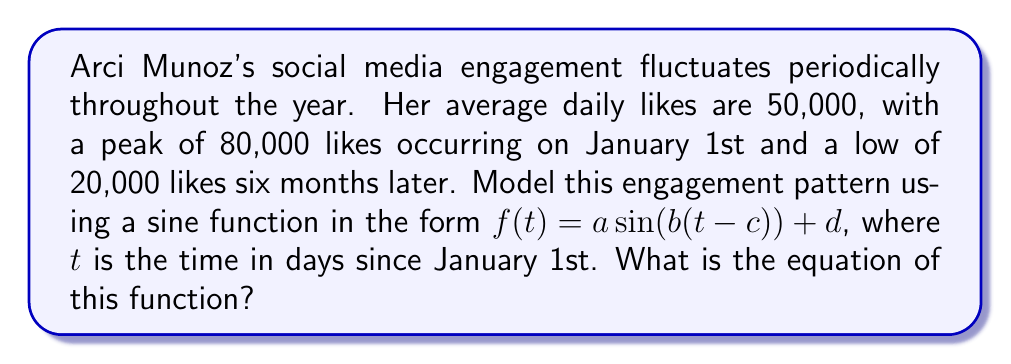Solve this math problem. Let's approach this step-by-step:

1) The general form of a sine function is $f(t) = a \sin(b(t-c)) + d$, where:
   $a$ is the amplitude
   $b$ is the angular frequency
   $c$ is the phase shift
   $d$ is the vertical shift

2) Find the amplitude $a$:
   $a = \frac{\text{max} - \text{min}}{2} = \frac{80000 - 20000}{2} = 30000$

3) Find the vertical shift $d$:
   $d = \frac{\text{max} + \text{min}}{2} = \frac{80000 + 20000}{2} = 50000$

4) Find the period:
   The period is 1 year = 365 days
   $\text{Period} = \frac{2\pi}{b} \Rightarrow 365 = \frac{2\pi}{b}$
   $b = \frac{2\pi}{365} \approx 0.0172$

5) Find the phase shift $c$:
   The function starts at its maximum on January 1st, so $c = 0$

6) Putting it all together:
   $f(t) = 30000 \sin(0.0172t) + 50000$

Therefore, the equation modeling Arci Munoz's social media engagement over time is:
$f(t) = 30000 \sin(0.0172t) + 50000$, where $t$ is the number of days since January 1st.
Answer: $f(t) = 30000 \sin(0.0172t) + 50000$ 